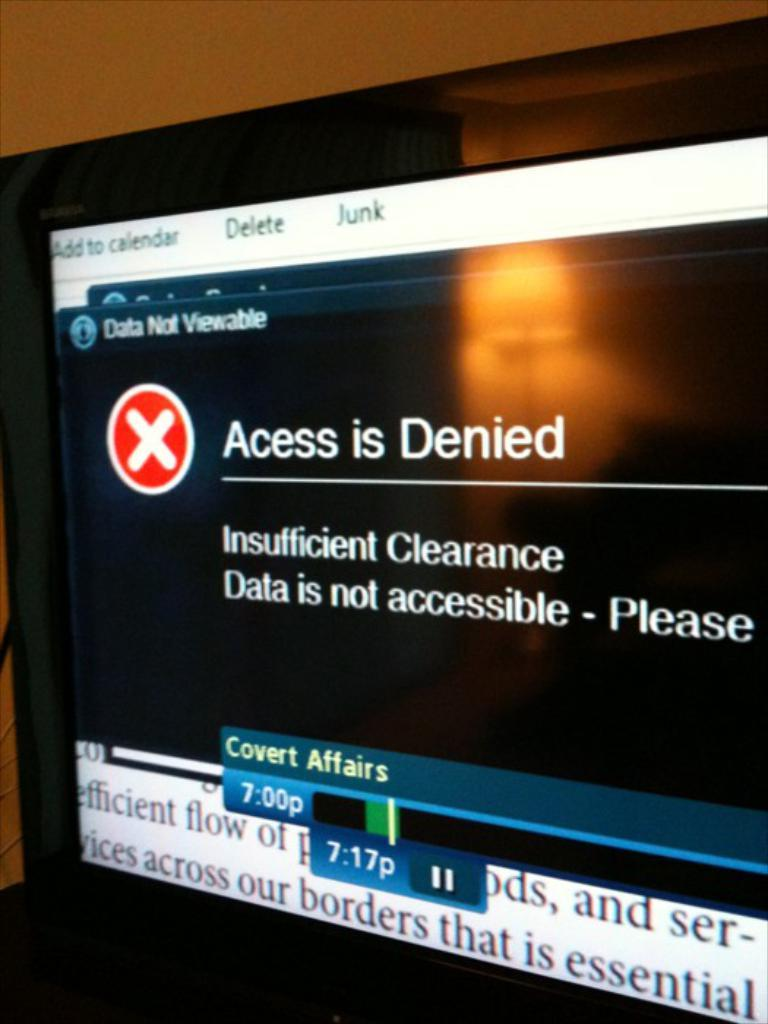<image>
Summarize the visual content of the image. A recording of Covert Affairs which the data isn't accessible. 